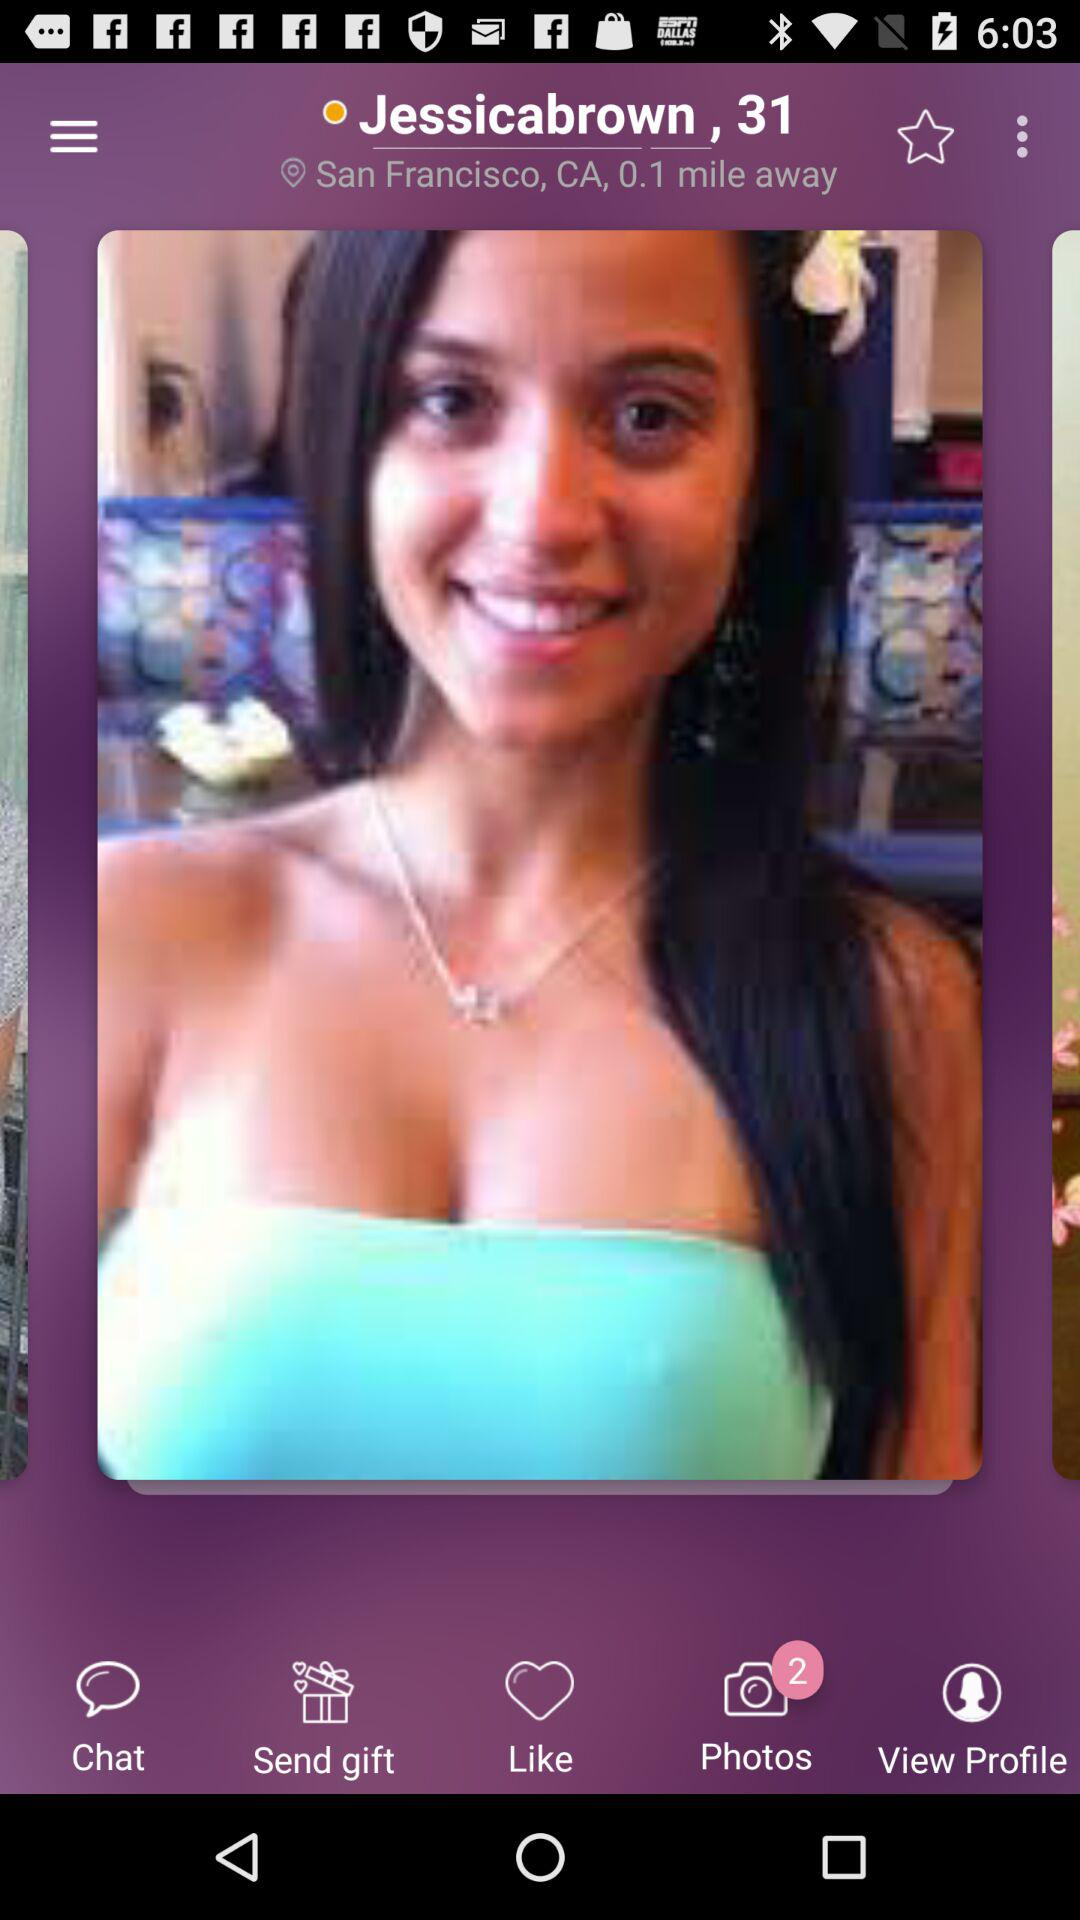What is the number of photos? The number of photos is 2. 